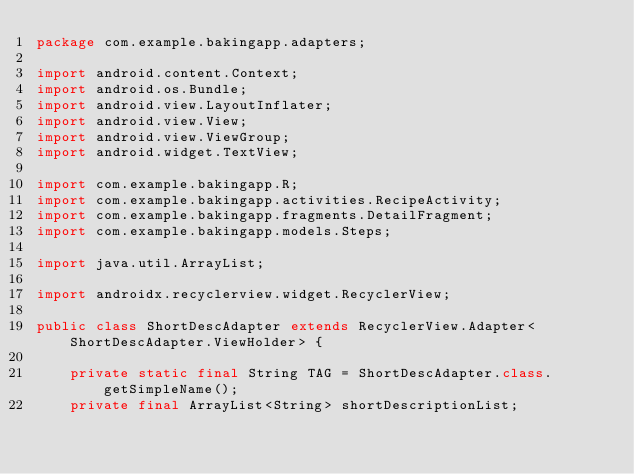<code> <loc_0><loc_0><loc_500><loc_500><_Java_>package com.example.bakingapp.adapters;

import android.content.Context;
import android.os.Bundle;
import android.view.LayoutInflater;
import android.view.View;
import android.view.ViewGroup;
import android.widget.TextView;

import com.example.bakingapp.R;
import com.example.bakingapp.activities.RecipeActivity;
import com.example.bakingapp.fragments.DetailFragment;
import com.example.bakingapp.models.Steps;

import java.util.ArrayList;

import androidx.recyclerview.widget.RecyclerView;

public class ShortDescAdapter extends RecyclerView.Adapter<ShortDescAdapter.ViewHolder> {

    private static final String TAG = ShortDescAdapter.class.getSimpleName();
    private final ArrayList<String> shortDescriptionList;</code> 